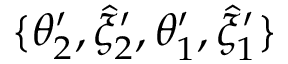Convert formula to latex. <formula><loc_0><loc_0><loc_500><loc_500>\{ \theta _ { 2 } ^ { \prime } , \hat { \xi } _ { 2 } ^ { \prime } , \theta _ { 1 } ^ { \prime } , \hat { \xi } _ { 1 } ^ { \prime } \}</formula> 